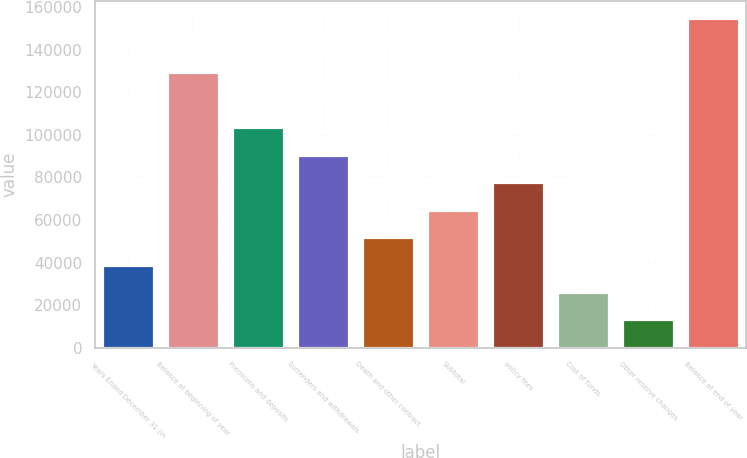Convert chart to OTSL. <chart><loc_0><loc_0><loc_500><loc_500><bar_chart><fcel>Years Ended December 31 (in<fcel>Balance at beginning of year<fcel>Premiums and deposits<fcel>Surrenders and withdrawals<fcel>Death and other contract<fcel>Subtotal<fcel>policy fees<fcel>Cost of funds<fcel>Other reserve changes<fcel>Balance at end of year<nl><fcel>39056<fcel>129321<fcel>103531<fcel>90636<fcel>51951<fcel>64846<fcel>77741<fcel>26161<fcel>13266<fcel>155111<nl></chart> 